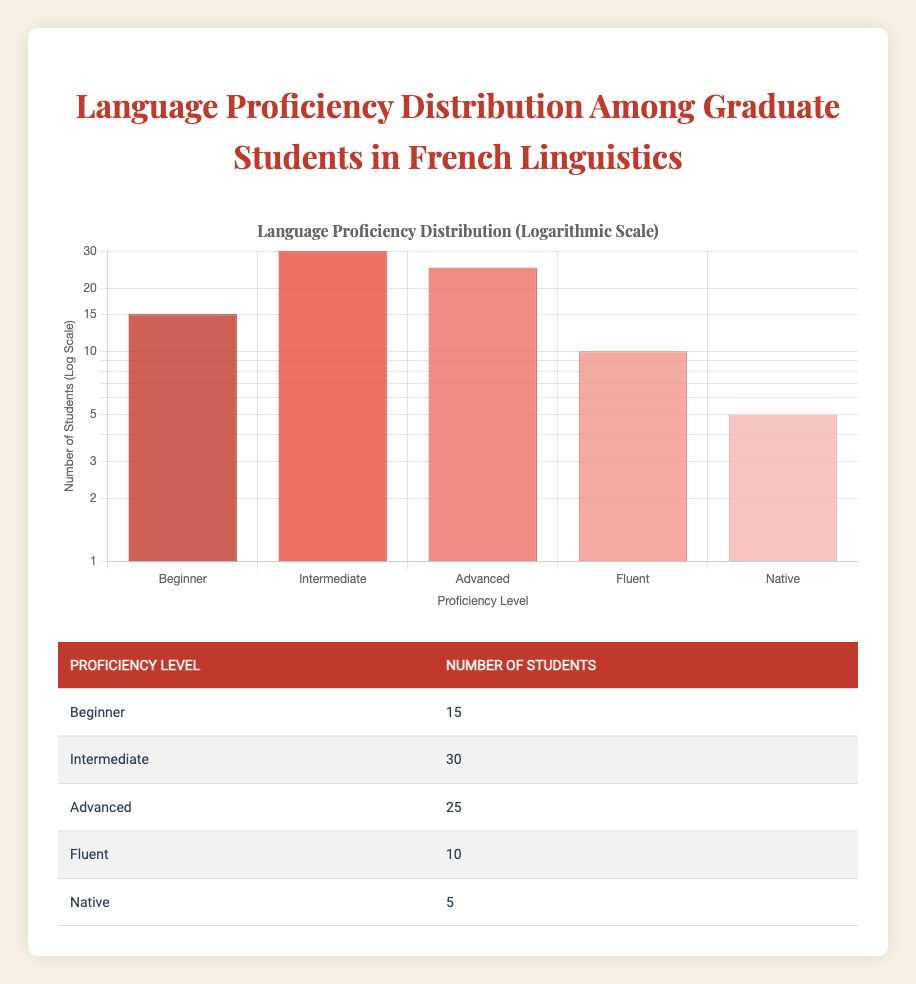What is the number of students at the Fluent level? The table clearly states that the Fluent level has 10 students listed under the "Number of Students" column.
Answer: 10 What is the total number of students represented in this table? To find the total number of students, sum the number of students across all proficiency levels: 15 (Beginner) + 30 (Intermediate) + 25 (Advanced) + 10 (Fluent) + 5 (Native) = 85.
Answer: 85 How many more students are at the Intermediate level compared to the Native level? The number of Intermediate students is 30, and the number of Native students is 5. The difference is 30 - 5 = 25.
Answer: 25 Is there a higher number of Advanced students than Fluent students? The table shows that there are 25 Advanced students and 10 Fluent students. Since 25 is greater than 10, this statement is true.
Answer: Yes What percentage of the total students are at the Beginner level? First, find the total number of students, which is 85. The number of Beginner students is 15. To find the percentage: (15/85) * 100 = 17.65%. Therefore, approximately 17.65% of the students are Beginners.
Answer: 17.65% 